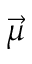<formula> <loc_0><loc_0><loc_500><loc_500>\vec { \mu }</formula> 